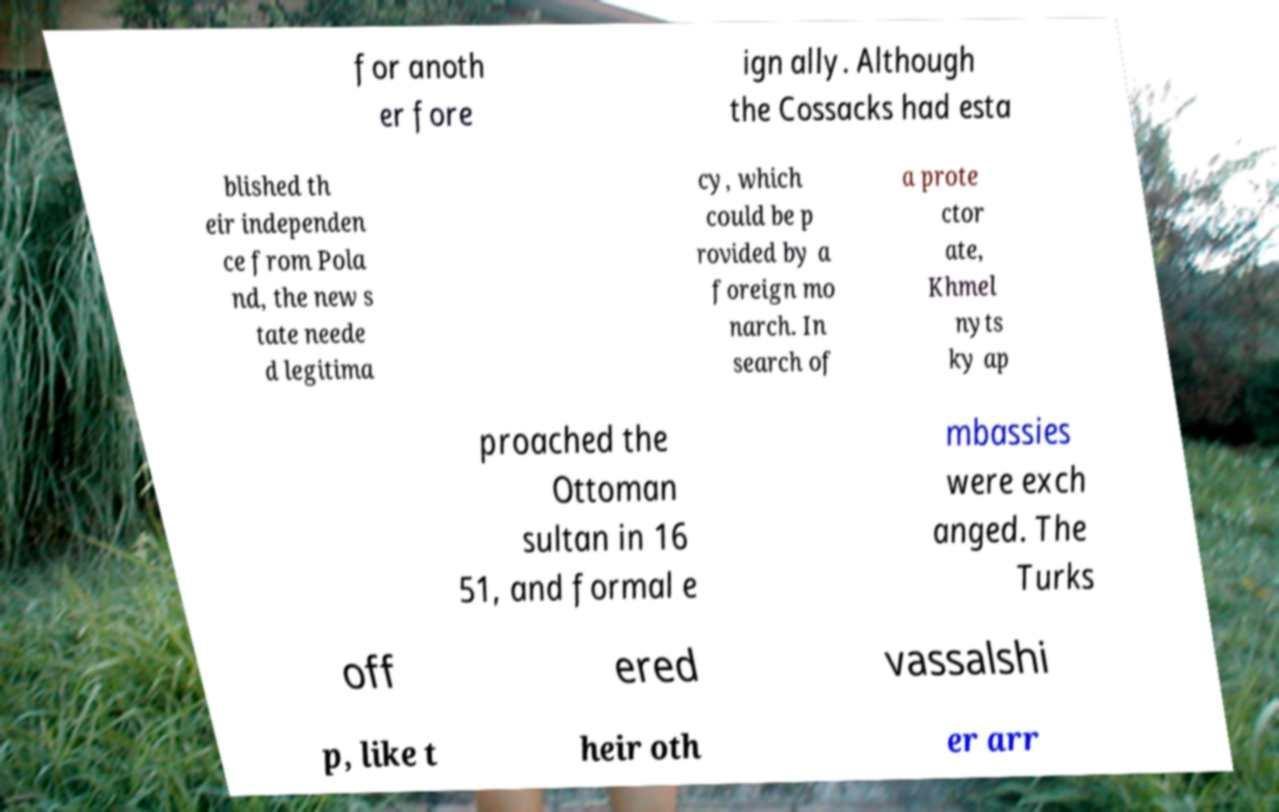There's text embedded in this image that I need extracted. Can you transcribe it verbatim? for anoth er fore ign ally. Although the Cossacks had esta blished th eir independen ce from Pola nd, the new s tate neede d legitima cy, which could be p rovided by a foreign mo narch. In search of a prote ctor ate, Khmel nyts ky ap proached the Ottoman sultan in 16 51, and formal e mbassies were exch anged. The Turks off ered vassalshi p, like t heir oth er arr 